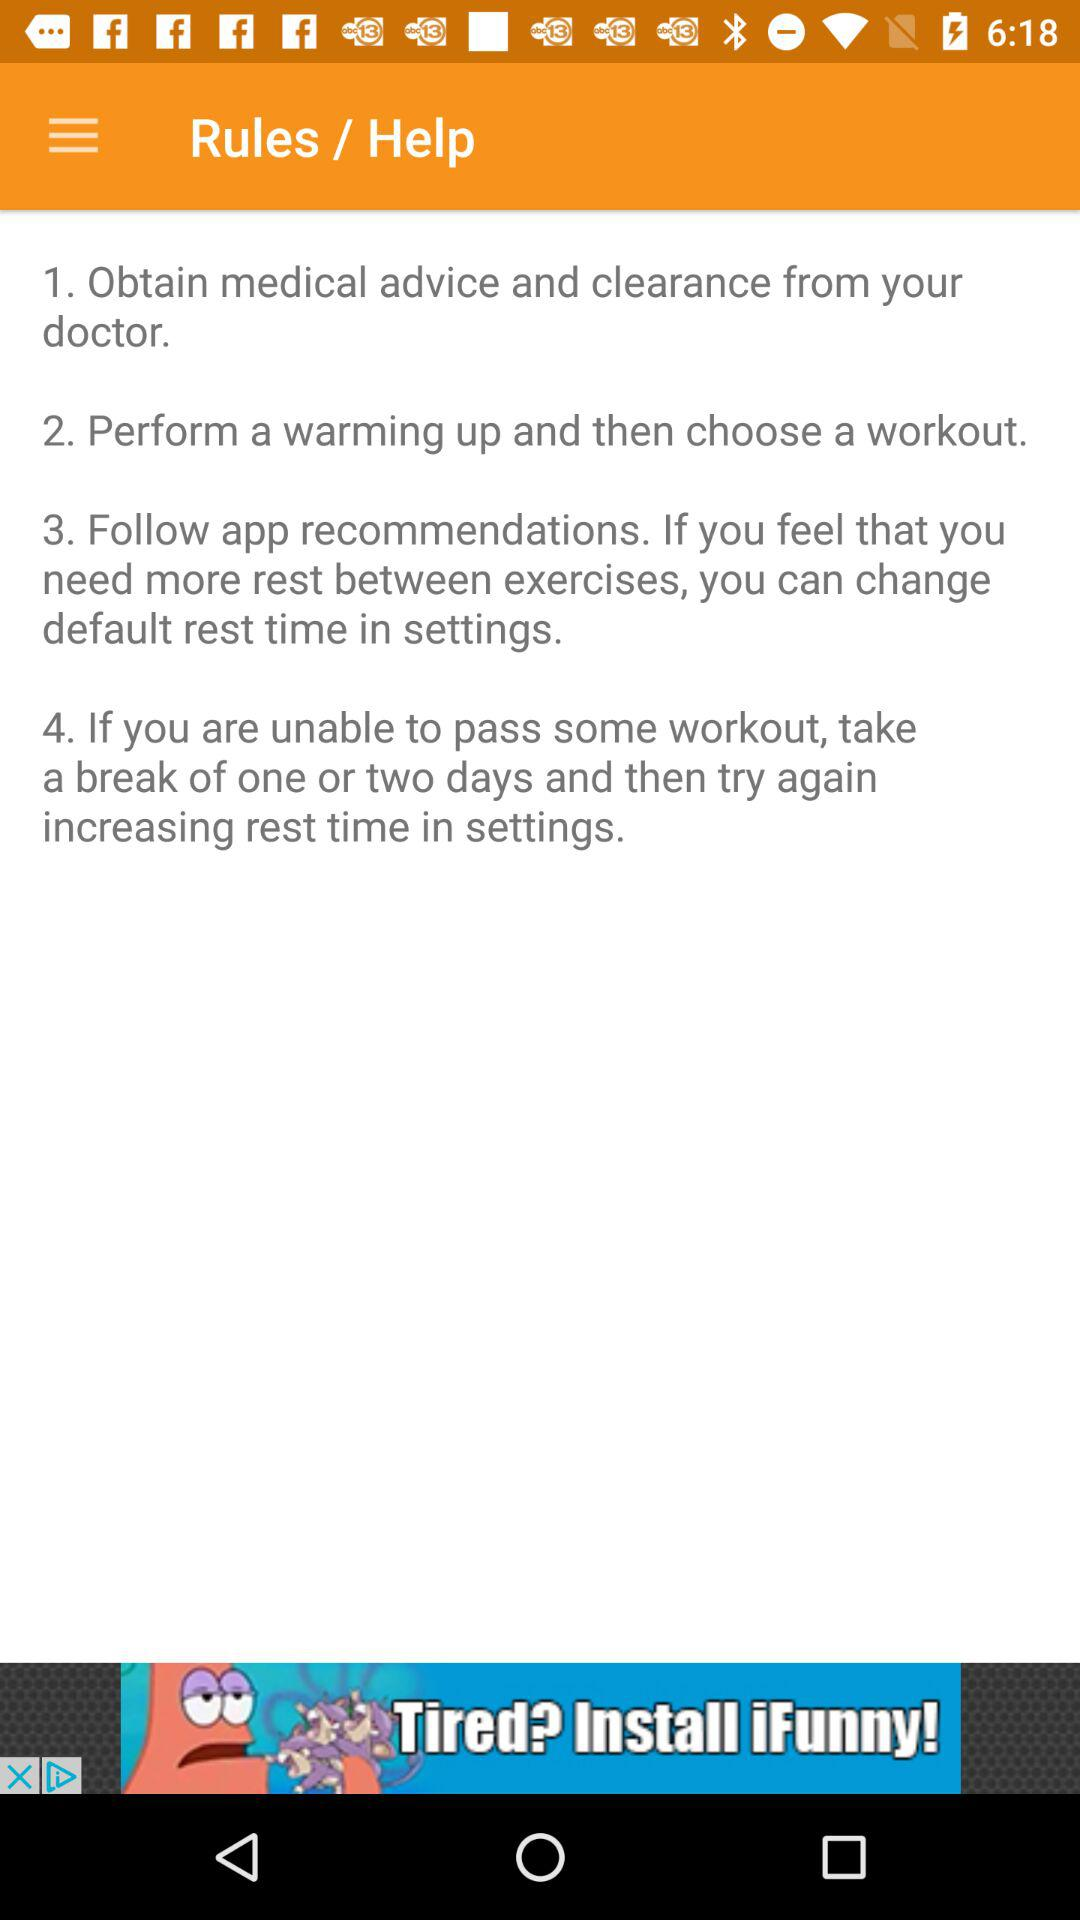How many steps are there in the rules of this app?
Answer the question using a single word or phrase. 4 